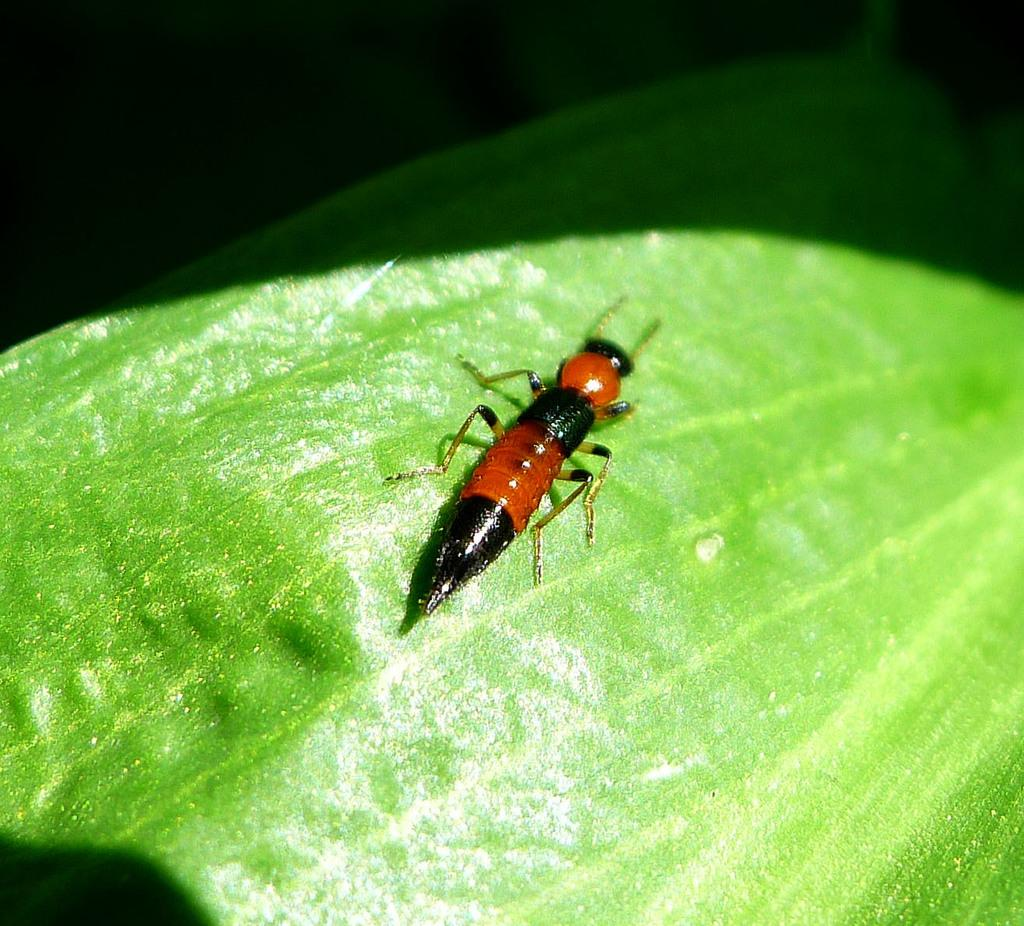What is present in the picture? There is an insect in the picture. Can you describe the insect's appearance? The insect has black and red color. Where is the insect located? The insect is on a leaf. How many babies are present in the picture? There are no babies present in the picture; it features an insect on a leaf. What type of dress is the insect wearing in the picture? The insect is not wearing a dress, as insects do not wear clothing. 